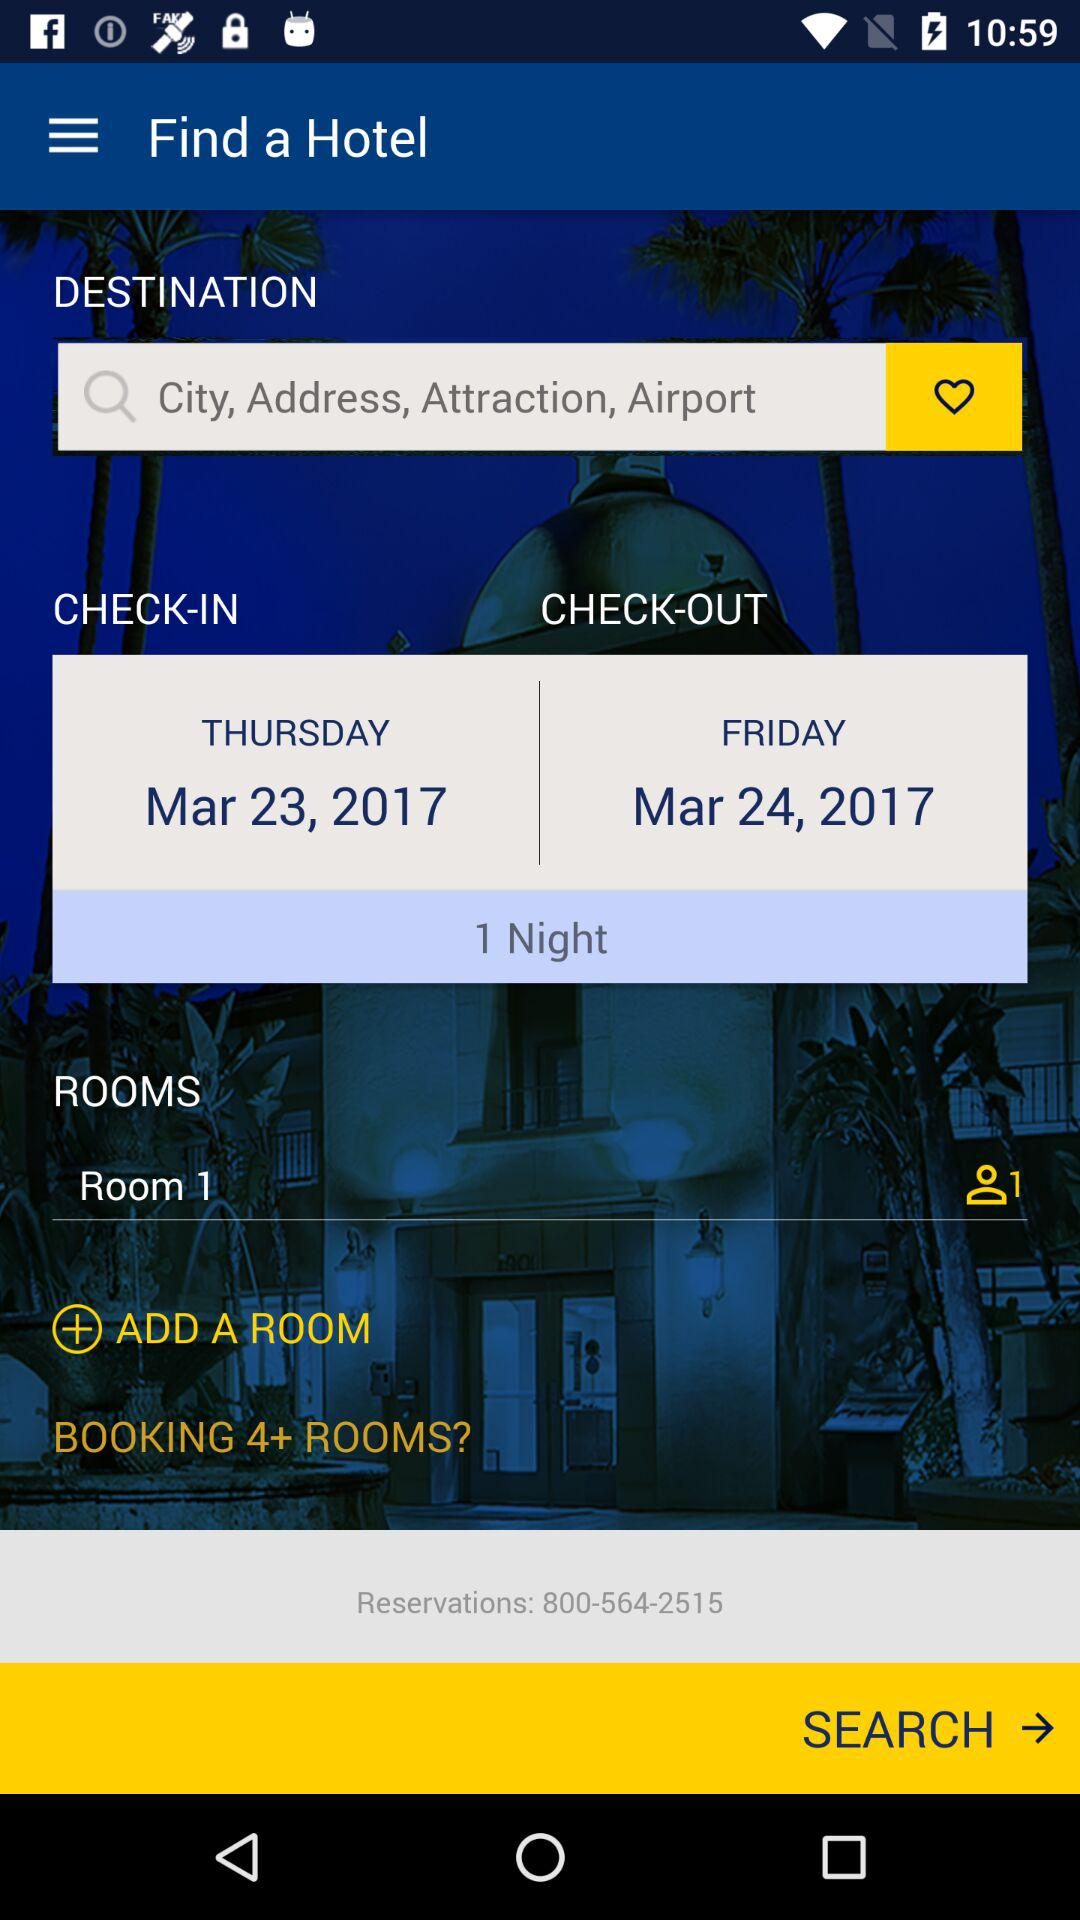What is the check out date? The check out date is March 24, 2017. 